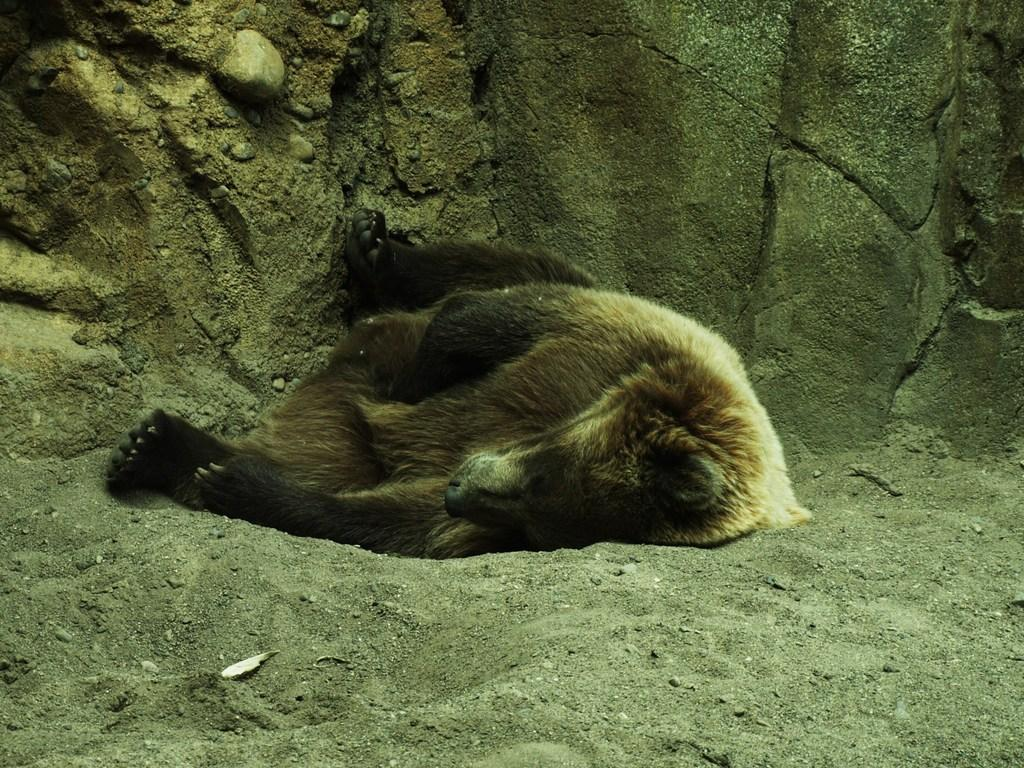What animal is present in the image? There is a bear in the image. What is the bear's position in the image? The bear is laying on the land. What can be seen in the background of the image? There is a stone wall in the background of the image. What type of cactus can be seen growing near the bear in the image? There is no cactus present in the image; it features a bear laying on the land with a stone wall in the background. 